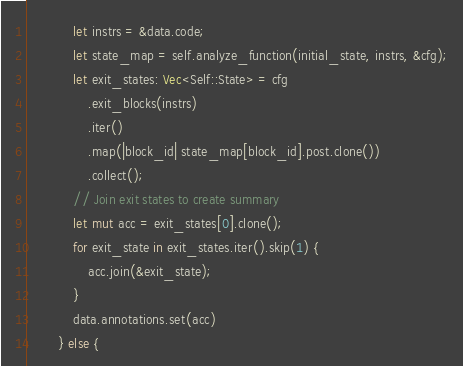<code> <loc_0><loc_0><loc_500><loc_500><_Rust_>            let instrs = &data.code;
            let state_map = self.analyze_function(initial_state, instrs, &cfg);
            let exit_states: Vec<Self::State> = cfg
                .exit_blocks(instrs)
                .iter()
                .map(|block_id| state_map[block_id].post.clone())
                .collect();
            // Join exit states to create summary
            let mut acc = exit_states[0].clone();
            for exit_state in exit_states.iter().skip(1) {
                acc.join(&exit_state);
            }
            data.annotations.set(acc)
        } else {</code> 